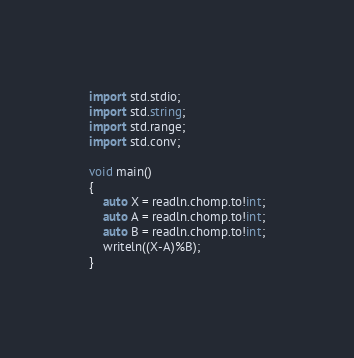Convert code to text. <code><loc_0><loc_0><loc_500><loc_500><_D_>import std.stdio;
import std.string;
import std.range;
import std.conv;

void main()
{
	auto X = readln.chomp.to!int;
	auto A = readln.chomp.to!int;
	auto B = readln.chomp.to!int;
	writeln((X-A)%B);
}</code> 